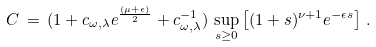Convert formula to latex. <formula><loc_0><loc_0><loc_500><loc_500>C \, = \, ( 1 + c _ { \omega , \lambda } e ^ { \frac { ( \mu + \epsilon ) } { 2 } } + c _ { \omega , \lambda } ^ { - 1 } ) \, \sup _ { s \geq 0 } \left [ ( 1 + s ) ^ { \nu + 1 } e ^ { - \epsilon s } \right ] \, .</formula> 